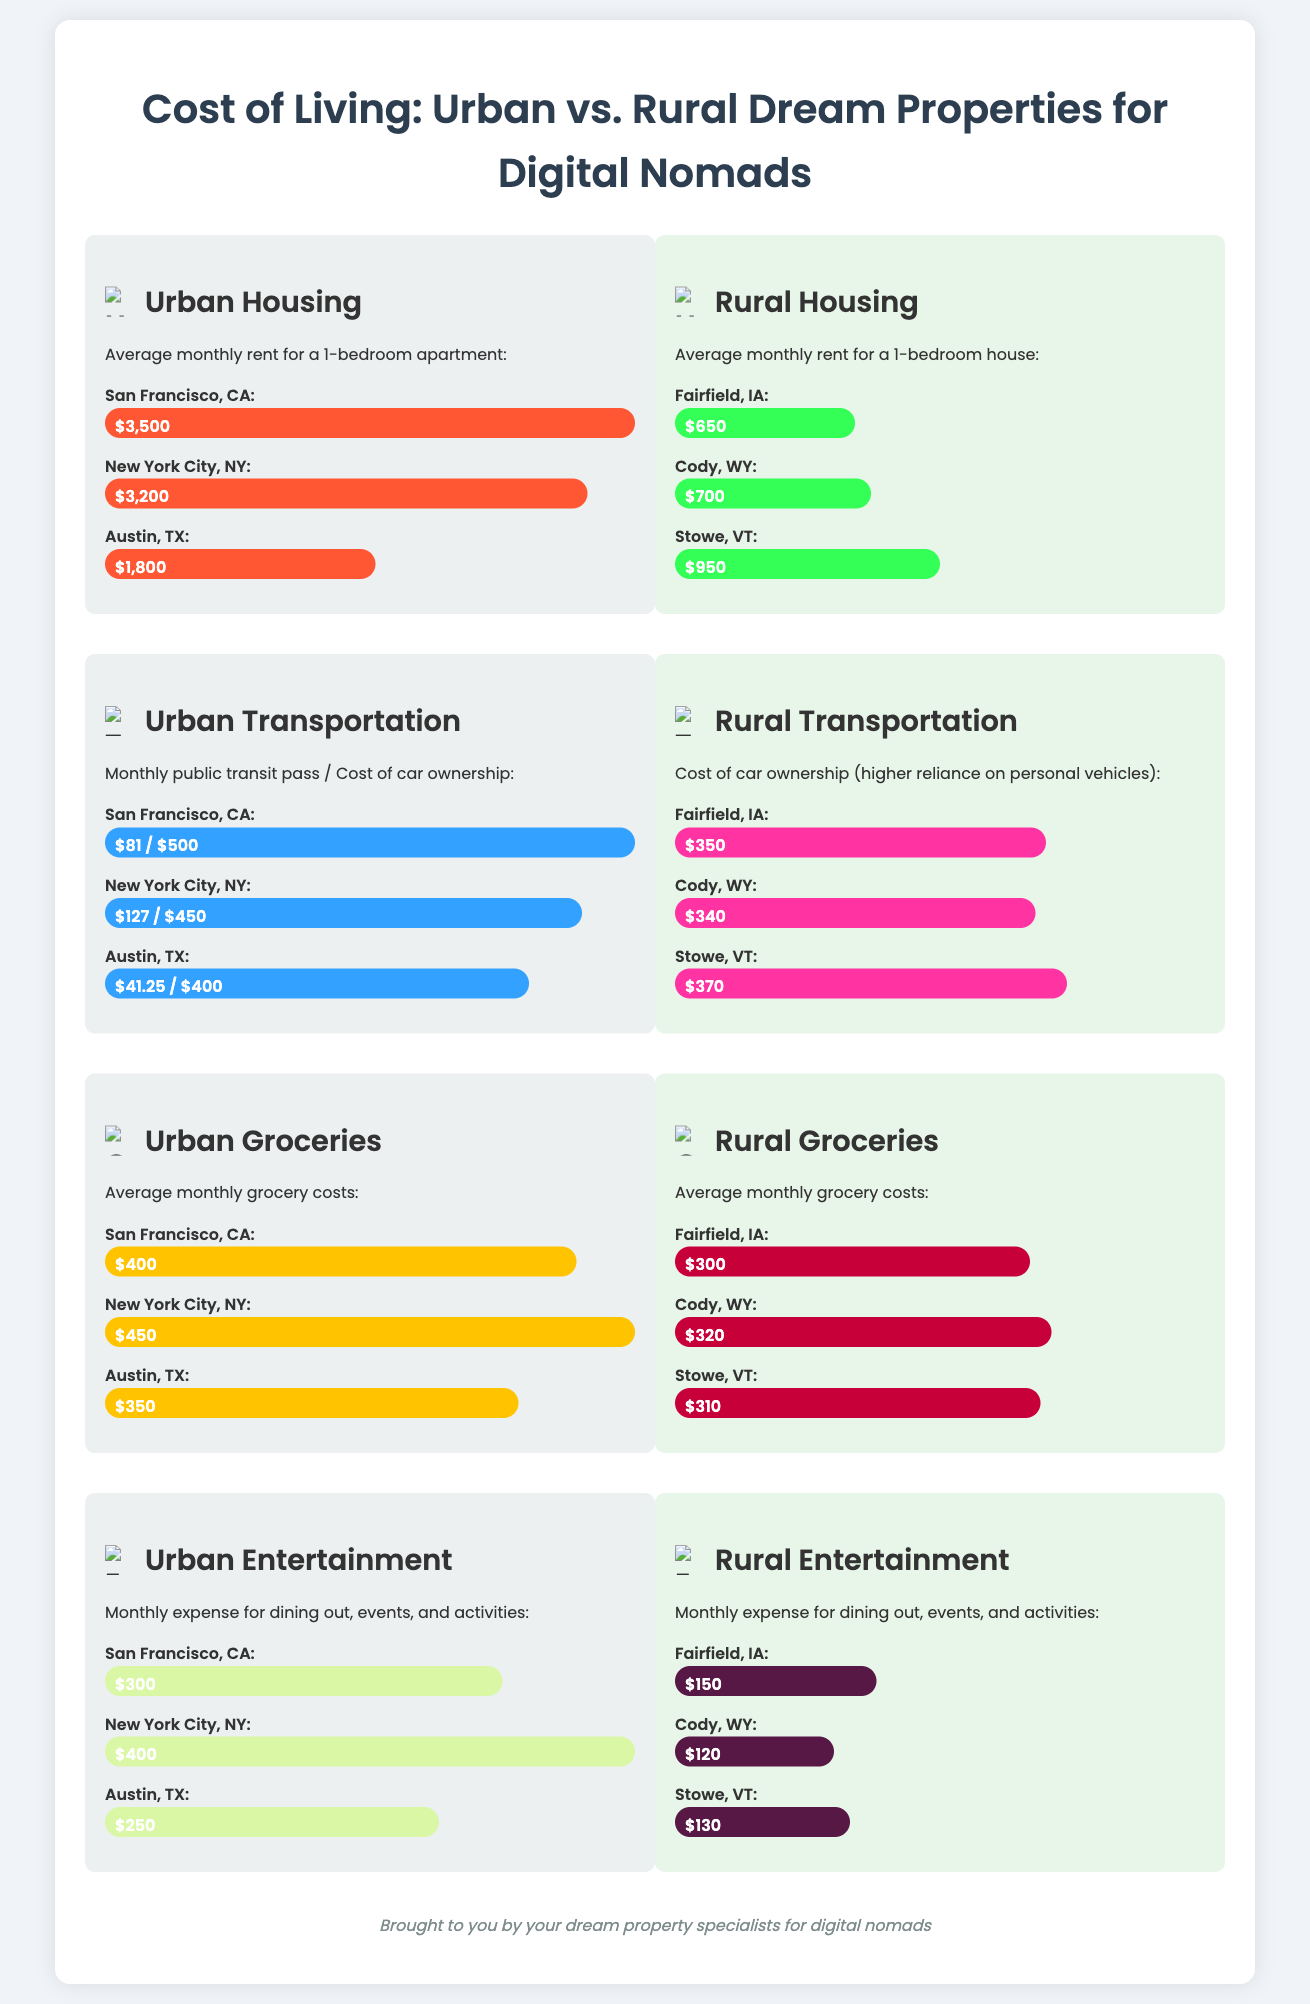What is the average monthly rent in San Francisco? The average monthly rent for a 1-bedroom apartment in San Francisco is presented as $3,500 in the urban housing section.
Answer: $3,500 What is the average monthly rent in Fairfield, IA? The average monthly rent for a 1-bedroom house in Fairfield, IA is listed as $650 in the rural housing section.
Answer: $650 Which city has the highest average monthly grocery costs? The document indicates that New York City has the highest average monthly grocery costs at $450.
Answer: New York City What is the monthly expense for entertainment in Cody, WY? The entertainment cost in Cody, WY is stated as $120 in the rural entertainment section.
Answer: $120 Which city has a transportation cost of $81? In the urban transportation section, San Francisco is associated with a transportation cost of $81.
Answer: San Francisco How much is the average grocery expense in rural areas? The average grocery expense in rural areas is detailed in the document across multiple cities, the values being $300, $320, and $310, with a summary reference needed; here it will be estimated as around $310 for succinctness.
Answer: $310 What is the cost of car ownership in Stowe, VT? The document shows that the cost of car ownership in Stowe, VT is $370.
Answer: $370 Which urban area has the lowest transportation cost? The urban transportation cost in Austin, TX is the lowest at $41.25 for public transit.
Answer: Austin, TX What color represents urban housing costs in the infographic? The urban housing costs are represented using a shade of orange, specifically #FF5733.
Answer: Orange 